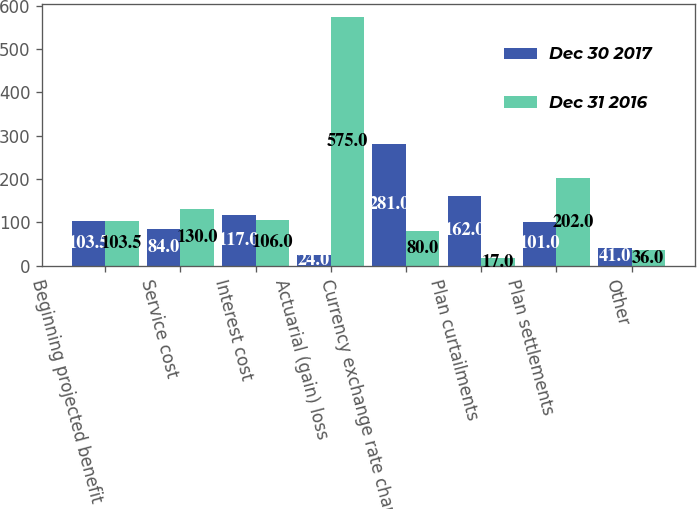Convert chart to OTSL. <chart><loc_0><loc_0><loc_500><loc_500><stacked_bar_chart><ecel><fcel>Beginning projected benefit<fcel>Service cost<fcel>Interest cost<fcel>Actuarial (gain) loss<fcel>Currency exchange rate changes<fcel>Plan curtailments<fcel>Plan settlements<fcel>Other<nl><fcel>Dec 30 2017<fcel>103.5<fcel>84<fcel>117<fcel>24<fcel>281<fcel>162<fcel>101<fcel>41<nl><fcel>Dec 31 2016<fcel>103.5<fcel>130<fcel>106<fcel>575<fcel>80<fcel>17<fcel>202<fcel>36<nl></chart> 